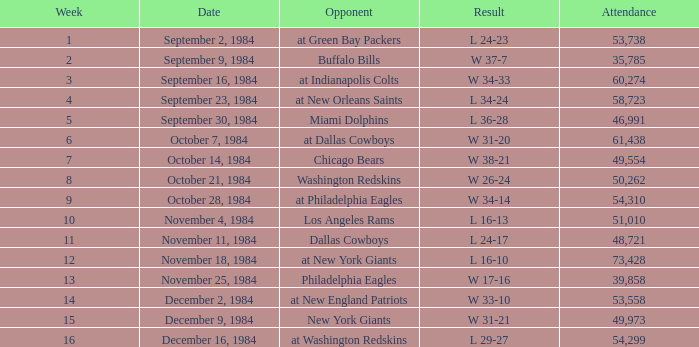For a game with a 16-13 result, what was the sum of attendees? 51010.0. 